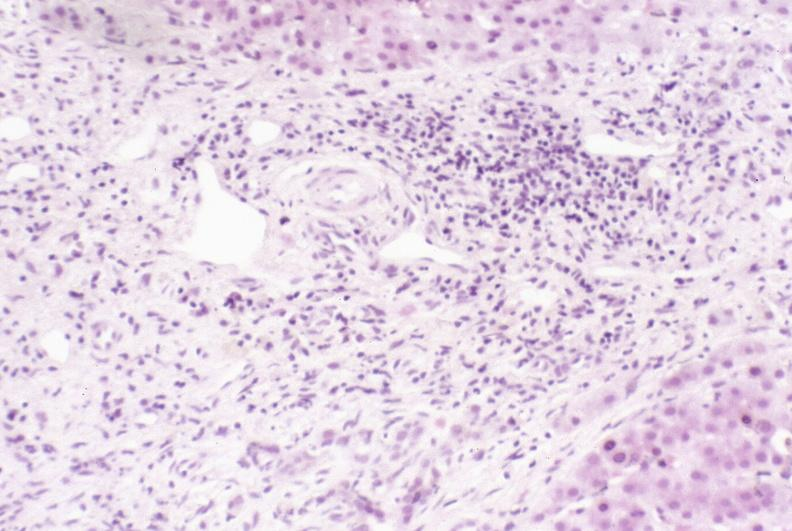what does this image show?
Answer the question using a single word or phrase. Primary sclerosing cholangitis 